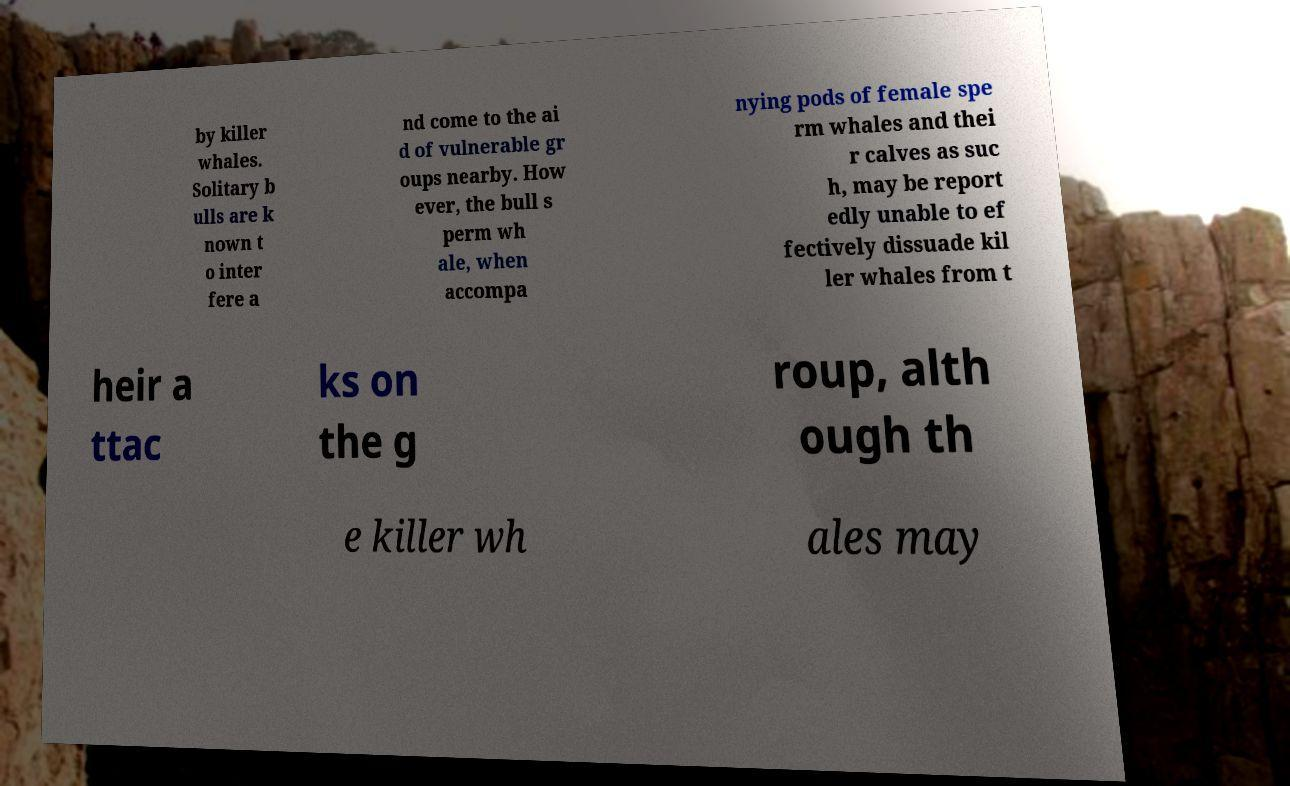Could you assist in decoding the text presented in this image and type it out clearly? by killer whales. Solitary b ulls are k nown t o inter fere a nd come to the ai d of vulnerable gr oups nearby. How ever, the bull s perm wh ale, when accompa nying pods of female spe rm whales and thei r calves as suc h, may be report edly unable to ef fectively dissuade kil ler whales from t heir a ttac ks on the g roup, alth ough th e killer wh ales may 